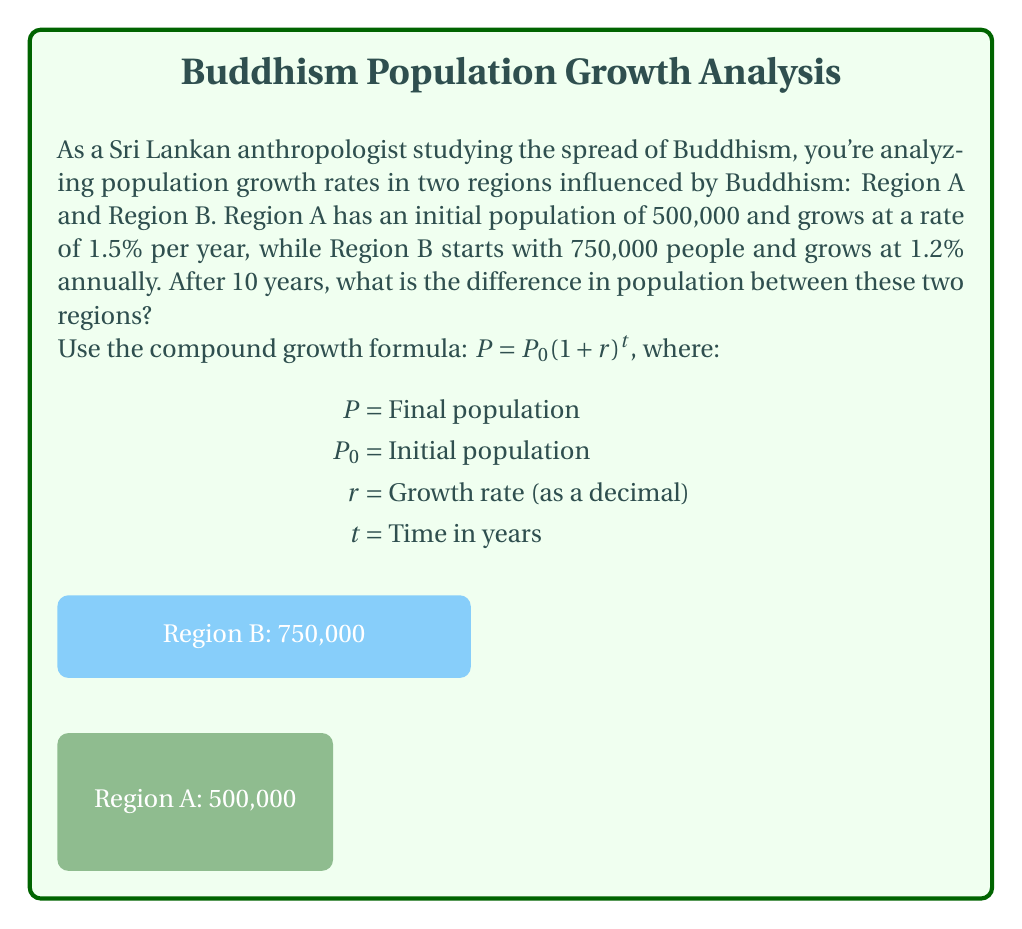What is the answer to this math problem? Let's solve this step-by-step:

1) For Region A:
   $P_A = 500,000(1 + 0.015)^{10}$
   $= 500,000(1.015)^{10}$
   $= 500,000 * 1.1605$
   $= 580,250$

2) For Region B:
   $P_B = 750,000(1 + 0.012)^{10}$
   $= 750,000(1.012)^{10}$
   $= 750,000 * 1.1268$
   $= 845,100$

3) Difference in population:
   $845,100 - 580,250 = 264,850$

Therefore, after 10 years, Region B will have 264,850 more people than Region A.
Answer: 264,850 